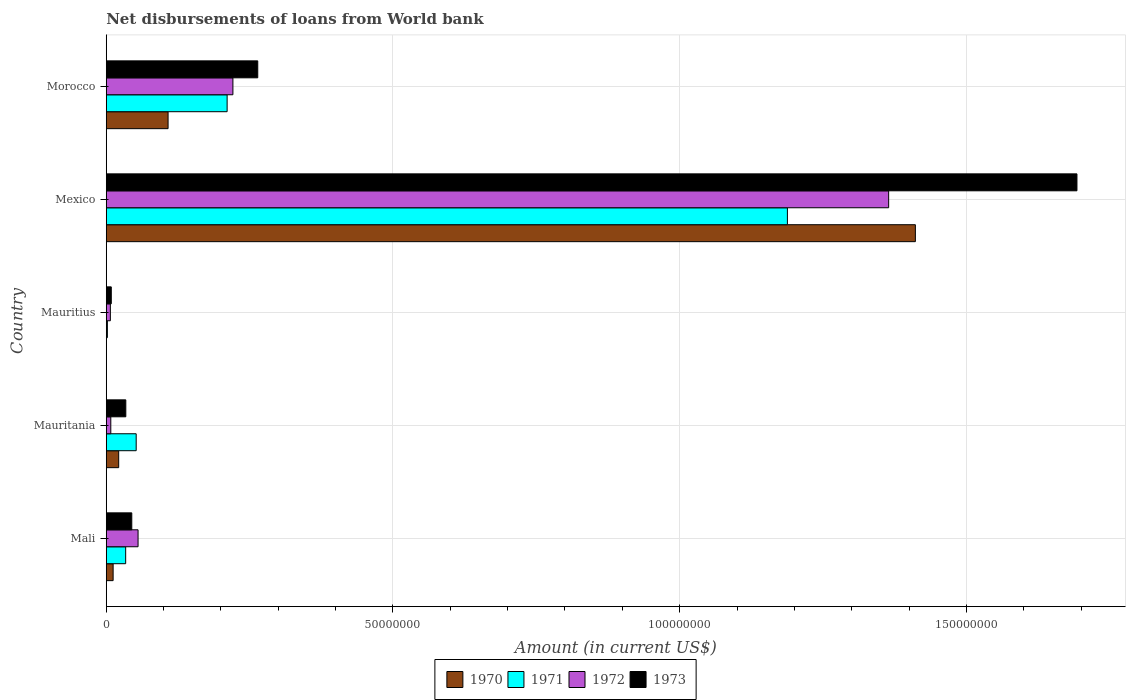How many groups of bars are there?
Make the answer very short. 5. Are the number of bars per tick equal to the number of legend labels?
Give a very brief answer. No. What is the label of the 3rd group of bars from the top?
Give a very brief answer. Mauritius. In how many cases, is the number of bars for a given country not equal to the number of legend labels?
Your answer should be compact. 1. What is the amount of loan disbursed from World Bank in 1972 in Mauritania?
Make the answer very short. 7.93e+05. Across all countries, what is the maximum amount of loan disbursed from World Bank in 1973?
Your response must be concise. 1.69e+08. Across all countries, what is the minimum amount of loan disbursed from World Bank in 1970?
Give a very brief answer. 0. What is the total amount of loan disbursed from World Bank in 1971 in the graph?
Ensure brevity in your answer.  1.49e+08. What is the difference between the amount of loan disbursed from World Bank in 1973 in Mali and that in Mauritius?
Provide a succinct answer. 3.57e+06. What is the difference between the amount of loan disbursed from World Bank in 1970 in Mauritius and the amount of loan disbursed from World Bank in 1972 in Mexico?
Ensure brevity in your answer.  -1.36e+08. What is the average amount of loan disbursed from World Bank in 1970 per country?
Your answer should be very brief. 3.11e+07. What is the difference between the amount of loan disbursed from World Bank in 1970 and amount of loan disbursed from World Bank in 1971 in Mauritania?
Offer a very short reply. -3.05e+06. What is the ratio of the amount of loan disbursed from World Bank in 1970 in Mauritania to that in Mexico?
Provide a short and direct response. 0.02. What is the difference between the highest and the second highest amount of loan disbursed from World Bank in 1973?
Give a very brief answer. 1.43e+08. What is the difference between the highest and the lowest amount of loan disbursed from World Bank in 1972?
Provide a short and direct response. 1.36e+08. Is the sum of the amount of loan disbursed from World Bank in 1972 in Mauritania and Mexico greater than the maximum amount of loan disbursed from World Bank in 1973 across all countries?
Keep it short and to the point. No. How many bars are there?
Provide a succinct answer. 19. What is the difference between two consecutive major ticks on the X-axis?
Give a very brief answer. 5.00e+07. Does the graph contain any zero values?
Give a very brief answer. Yes. Does the graph contain grids?
Ensure brevity in your answer.  Yes. What is the title of the graph?
Provide a succinct answer. Net disbursements of loans from World bank. Does "1988" appear as one of the legend labels in the graph?
Your answer should be compact. No. What is the label or title of the X-axis?
Your answer should be compact. Amount (in current US$). What is the label or title of the Y-axis?
Offer a terse response. Country. What is the Amount (in current US$) of 1970 in Mali?
Your answer should be very brief. 1.20e+06. What is the Amount (in current US$) in 1971 in Mali?
Provide a succinct answer. 3.39e+06. What is the Amount (in current US$) of 1972 in Mali?
Offer a very short reply. 5.55e+06. What is the Amount (in current US$) of 1973 in Mali?
Offer a very short reply. 4.45e+06. What is the Amount (in current US$) in 1970 in Mauritania?
Make the answer very short. 2.17e+06. What is the Amount (in current US$) of 1971 in Mauritania?
Give a very brief answer. 5.22e+06. What is the Amount (in current US$) of 1972 in Mauritania?
Keep it short and to the point. 7.93e+05. What is the Amount (in current US$) in 1973 in Mauritania?
Your response must be concise. 3.41e+06. What is the Amount (in current US$) in 1971 in Mauritius?
Make the answer very short. 1.99e+05. What is the Amount (in current US$) in 1972 in Mauritius?
Ensure brevity in your answer.  7.17e+05. What is the Amount (in current US$) in 1973 in Mauritius?
Keep it short and to the point. 8.79e+05. What is the Amount (in current US$) of 1970 in Mexico?
Offer a very short reply. 1.41e+08. What is the Amount (in current US$) in 1971 in Mexico?
Ensure brevity in your answer.  1.19e+08. What is the Amount (in current US$) in 1972 in Mexico?
Your answer should be very brief. 1.36e+08. What is the Amount (in current US$) in 1973 in Mexico?
Make the answer very short. 1.69e+08. What is the Amount (in current US$) in 1970 in Morocco?
Give a very brief answer. 1.08e+07. What is the Amount (in current US$) in 1971 in Morocco?
Your answer should be very brief. 2.11e+07. What is the Amount (in current US$) of 1972 in Morocco?
Your answer should be very brief. 2.21e+07. What is the Amount (in current US$) of 1973 in Morocco?
Ensure brevity in your answer.  2.64e+07. Across all countries, what is the maximum Amount (in current US$) of 1970?
Your response must be concise. 1.41e+08. Across all countries, what is the maximum Amount (in current US$) in 1971?
Your answer should be very brief. 1.19e+08. Across all countries, what is the maximum Amount (in current US$) of 1972?
Make the answer very short. 1.36e+08. Across all countries, what is the maximum Amount (in current US$) in 1973?
Provide a succinct answer. 1.69e+08. Across all countries, what is the minimum Amount (in current US$) of 1971?
Provide a short and direct response. 1.99e+05. Across all countries, what is the minimum Amount (in current US$) in 1972?
Make the answer very short. 7.17e+05. Across all countries, what is the minimum Amount (in current US$) of 1973?
Offer a very short reply. 8.79e+05. What is the total Amount (in current US$) of 1970 in the graph?
Your answer should be compact. 1.55e+08. What is the total Amount (in current US$) in 1971 in the graph?
Ensure brevity in your answer.  1.49e+08. What is the total Amount (in current US$) in 1972 in the graph?
Your answer should be very brief. 1.66e+08. What is the total Amount (in current US$) in 1973 in the graph?
Provide a short and direct response. 2.04e+08. What is the difference between the Amount (in current US$) of 1970 in Mali and that in Mauritania?
Ensure brevity in your answer.  -9.70e+05. What is the difference between the Amount (in current US$) in 1971 in Mali and that in Mauritania?
Give a very brief answer. -1.83e+06. What is the difference between the Amount (in current US$) in 1972 in Mali and that in Mauritania?
Provide a succinct answer. 4.76e+06. What is the difference between the Amount (in current US$) of 1973 in Mali and that in Mauritania?
Offer a terse response. 1.04e+06. What is the difference between the Amount (in current US$) in 1971 in Mali and that in Mauritius?
Provide a succinct answer. 3.19e+06. What is the difference between the Amount (in current US$) in 1972 in Mali and that in Mauritius?
Keep it short and to the point. 4.83e+06. What is the difference between the Amount (in current US$) in 1973 in Mali and that in Mauritius?
Give a very brief answer. 3.57e+06. What is the difference between the Amount (in current US$) of 1970 in Mali and that in Mexico?
Make the answer very short. -1.40e+08. What is the difference between the Amount (in current US$) in 1971 in Mali and that in Mexico?
Ensure brevity in your answer.  -1.15e+08. What is the difference between the Amount (in current US$) of 1972 in Mali and that in Mexico?
Your answer should be very brief. -1.31e+08. What is the difference between the Amount (in current US$) of 1973 in Mali and that in Mexico?
Provide a succinct answer. -1.65e+08. What is the difference between the Amount (in current US$) in 1970 in Mali and that in Morocco?
Your response must be concise. -9.58e+06. What is the difference between the Amount (in current US$) in 1971 in Mali and that in Morocco?
Your response must be concise. -1.77e+07. What is the difference between the Amount (in current US$) of 1972 in Mali and that in Morocco?
Make the answer very short. -1.65e+07. What is the difference between the Amount (in current US$) in 1973 in Mali and that in Morocco?
Offer a very short reply. -2.20e+07. What is the difference between the Amount (in current US$) in 1971 in Mauritania and that in Mauritius?
Ensure brevity in your answer.  5.02e+06. What is the difference between the Amount (in current US$) of 1972 in Mauritania and that in Mauritius?
Your answer should be very brief. 7.60e+04. What is the difference between the Amount (in current US$) of 1973 in Mauritania and that in Mauritius?
Give a very brief answer. 2.53e+06. What is the difference between the Amount (in current US$) of 1970 in Mauritania and that in Mexico?
Make the answer very short. -1.39e+08. What is the difference between the Amount (in current US$) of 1971 in Mauritania and that in Mexico?
Your response must be concise. -1.14e+08. What is the difference between the Amount (in current US$) in 1972 in Mauritania and that in Mexico?
Keep it short and to the point. -1.36e+08. What is the difference between the Amount (in current US$) of 1973 in Mauritania and that in Mexico?
Offer a very short reply. -1.66e+08. What is the difference between the Amount (in current US$) in 1970 in Mauritania and that in Morocco?
Provide a short and direct response. -8.61e+06. What is the difference between the Amount (in current US$) of 1971 in Mauritania and that in Morocco?
Your response must be concise. -1.59e+07. What is the difference between the Amount (in current US$) of 1972 in Mauritania and that in Morocco?
Provide a short and direct response. -2.13e+07. What is the difference between the Amount (in current US$) of 1973 in Mauritania and that in Morocco?
Keep it short and to the point. -2.30e+07. What is the difference between the Amount (in current US$) of 1971 in Mauritius and that in Mexico?
Provide a succinct answer. -1.19e+08. What is the difference between the Amount (in current US$) of 1972 in Mauritius and that in Mexico?
Ensure brevity in your answer.  -1.36e+08. What is the difference between the Amount (in current US$) of 1973 in Mauritius and that in Mexico?
Your response must be concise. -1.68e+08. What is the difference between the Amount (in current US$) in 1971 in Mauritius and that in Morocco?
Offer a terse response. -2.09e+07. What is the difference between the Amount (in current US$) in 1972 in Mauritius and that in Morocco?
Provide a succinct answer. -2.14e+07. What is the difference between the Amount (in current US$) of 1973 in Mauritius and that in Morocco?
Offer a very short reply. -2.55e+07. What is the difference between the Amount (in current US$) of 1970 in Mexico and that in Morocco?
Your answer should be compact. 1.30e+08. What is the difference between the Amount (in current US$) of 1971 in Mexico and that in Morocco?
Provide a short and direct response. 9.77e+07. What is the difference between the Amount (in current US$) in 1972 in Mexico and that in Morocco?
Provide a short and direct response. 1.14e+08. What is the difference between the Amount (in current US$) of 1973 in Mexico and that in Morocco?
Provide a short and direct response. 1.43e+08. What is the difference between the Amount (in current US$) in 1970 in Mali and the Amount (in current US$) in 1971 in Mauritania?
Offer a terse response. -4.02e+06. What is the difference between the Amount (in current US$) in 1970 in Mali and the Amount (in current US$) in 1972 in Mauritania?
Ensure brevity in your answer.  4.07e+05. What is the difference between the Amount (in current US$) of 1970 in Mali and the Amount (in current US$) of 1973 in Mauritania?
Give a very brief answer. -2.21e+06. What is the difference between the Amount (in current US$) in 1971 in Mali and the Amount (in current US$) in 1972 in Mauritania?
Ensure brevity in your answer.  2.60e+06. What is the difference between the Amount (in current US$) in 1971 in Mali and the Amount (in current US$) in 1973 in Mauritania?
Offer a terse response. -2.30e+04. What is the difference between the Amount (in current US$) of 1972 in Mali and the Amount (in current US$) of 1973 in Mauritania?
Ensure brevity in your answer.  2.14e+06. What is the difference between the Amount (in current US$) in 1970 in Mali and the Amount (in current US$) in 1971 in Mauritius?
Offer a very short reply. 1.00e+06. What is the difference between the Amount (in current US$) of 1970 in Mali and the Amount (in current US$) of 1972 in Mauritius?
Ensure brevity in your answer.  4.83e+05. What is the difference between the Amount (in current US$) of 1970 in Mali and the Amount (in current US$) of 1973 in Mauritius?
Your answer should be compact. 3.21e+05. What is the difference between the Amount (in current US$) of 1971 in Mali and the Amount (in current US$) of 1972 in Mauritius?
Make the answer very short. 2.67e+06. What is the difference between the Amount (in current US$) of 1971 in Mali and the Amount (in current US$) of 1973 in Mauritius?
Ensure brevity in your answer.  2.51e+06. What is the difference between the Amount (in current US$) in 1972 in Mali and the Amount (in current US$) in 1973 in Mauritius?
Your response must be concise. 4.67e+06. What is the difference between the Amount (in current US$) of 1970 in Mali and the Amount (in current US$) of 1971 in Mexico?
Provide a succinct answer. -1.18e+08. What is the difference between the Amount (in current US$) in 1970 in Mali and the Amount (in current US$) in 1972 in Mexico?
Provide a succinct answer. -1.35e+08. What is the difference between the Amount (in current US$) of 1970 in Mali and the Amount (in current US$) of 1973 in Mexico?
Your answer should be very brief. -1.68e+08. What is the difference between the Amount (in current US$) in 1971 in Mali and the Amount (in current US$) in 1972 in Mexico?
Ensure brevity in your answer.  -1.33e+08. What is the difference between the Amount (in current US$) in 1971 in Mali and the Amount (in current US$) in 1973 in Mexico?
Provide a succinct answer. -1.66e+08. What is the difference between the Amount (in current US$) of 1972 in Mali and the Amount (in current US$) of 1973 in Mexico?
Your answer should be compact. -1.64e+08. What is the difference between the Amount (in current US$) in 1970 in Mali and the Amount (in current US$) in 1971 in Morocco?
Your answer should be very brief. -1.99e+07. What is the difference between the Amount (in current US$) of 1970 in Mali and the Amount (in current US$) of 1972 in Morocco?
Make the answer very short. -2.09e+07. What is the difference between the Amount (in current US$) in 1970 in Mali and the Amount (in current US$) in 1973 in Morocco?
Give a very brief answer. -2.52e+07. What is the difference between the Amount (in current US$) of 1971 in Mali and the Amount (in current US$) of 1972 in Morocco?
Provide a short and direct response. -1.87e+07. What is the difference between the Amount (in current US$) in 1971 in Mali and the Amount (in current US$) in 1973 in Morocco?
Ensure brevity in your answer.  -2.30e+07. What is the difference between the Amount (in current US$) of 1972 in Mali and the Amount (in current US$) of 1973 in Morocco?
Ensure brevity in your answer.  -2.09e+07. What is the difference between the Amount (in current US$) in 1970 in Mauritania and the Amount (in current US$) in 1971 in Mauritius?
Give a very brief answer. 1.97e+06. What is the difference between the Amount (in current US$) of 1970 in Mauritania and the Amount (in current US$) of 1972 in Mauritius?
Give a very brief answer. 1.45e+06. What is the difference between the Amount (in current US$) in 1970 in Mauritania and the Amount (in current US$) in 1973 in Mauritius?
Provide a short and direct response. 1.29e+06. What is the difference between the Amount (in current US$) of 1971 in Mauritania and the Amount (in current US$) of 1972 in Mauritius?
Provide a succinct answer. 4.50e+06. What is the difference between the Amount (in current US$) in 1971 in Mauritania and the Amount (in current US$) in 1973 in Mauritius?
Keep it short and to the point. 4.34e+06. What is the difference between the Amount (in current US$) in 1972 in Mauritania and the Amount (in current US$) in 1973 in Mauritius?
Your answer should be very brief. -8.60e+04. What is the difference between the Amount (in current US$) of 1970 in Mauritania and the Amount (in current US$) of 1971 in Mexico?
Keep it short and to the point. -1.17e+08. What is the difference between the Amount (in current US$) in 1970 in Mauritania and the Amount (in current US$) in 1972 in Mexico?
Provide a succinct answer. -1.34e+08. What is the difference between the Amount (in current US$) in 1970 in Mauritania and the Amount (in current US$) in 1973 in Mexico?
Make the answer very short. -1.67e+08. What is the difference between the Amount (in current US$) of 1971 in Mauritania and the Amount (in current US$) of 1972 in Mexico?
Keep it short and to the point. -1.31e+08. What is the difference between the Amount (in current US$) of 1971 in Mauritania and the Amount (in current US$) of 1973 in Mexico?
Your response must be concise. -1.64e+08. What is the difference between the Amount (in current US$) in 1972 in Mauritania and the Amount (in current US$) in 1973 in Mexico?
Your answer should be very brief. -1.68e+08. What is the difference between the Amount (in current US$) in 1970 in Mauritania and the Amount (in current US$) in 1971 in Morocco?
Your answer should be very brief. -1.89e+07. What is the difference between the Amount (in current US$) of 1970 in Mauritania and the Amount (in current US$) of 1972 in Morocco?
Give a very brief answer. -1.99e+07. What is the difference between the Amount (in current US$) in 1970 in Mauritania and the Amount (in current US$) in 1973 in Morocco?
Your answer should be very brief. -2.43e+07. What is the difference between the Amount (in current US$) of 1971 in Mauritania and the Amount (in current US$) of 1972 in Morocco?
Offer a very short reply. -1.69e+07. What is the difference between the Amount (in current US$) of 1971 in Mauritania and the Amount (in current US$) of 1973 in Morocco?
Your response must be concise. -2.12e+07. What is the difference between the Amount (in current US$) of 1972 in Mauritania and the Amount (in current US$) of 1973 in Morocco?
Offer a terse response. -2.56e+07. What is the difference between the Amount (in current US$) in 1971 in Mauritius and the Amount (in current US$) in 1972 in Mexico?
Your response must be concise. -1.36e+08. What is the difference between the Amount (in current US$) in 1971 in Mauritius and the Amount (in current US$) in 1973 in Mexico?
Provide a short and direct response. -1.69e+08. What is the difference between the Amount (in current US$) of 1972 in Mauritius and the Amount (in current US$) of 1973 in Mexico?
Offer a very short reply. -1.69e+08. What is the difference between the Amount (in current US$) in 1971 in Mauritius and the Amount (in current US$) in 1972 in Morocco?
Offer a very short reply. -2.19e+07. What is the difference between the Amount (in current US$) of 1971 in Mauritius and the Amount (in current US$) of 1973 in Morocco?
Your answer should be very brief. -2.62e+07. What is the difference between the Amount (in current US$) in 1972 in Mauritius and the Amount (in current US$) in 1973 in Morocco?
Your response must be concise. -2.57e+07. What is the difference between the Amount (in current US$) of 1970 in Mexico and the Amount (in current US$) of 1971 in Morocco?
Give a very brief answer. 1.20e+08. What is the difference between the Amount (in current US$) in 1970 in Mexico and the Amount (in current US$) in 1972 in Morocco?
Give a very brief answer. 1.19e+08. What is the difference between the Amount (in current US$) in 1970 in Mexico and the Amount (in current US$) in 1973 in Morocco?
Offer a terse response. 1.15e+08. What is the difference between the Amount (in current US$) of 1971 in Mexico and the Amount (in current US$) of 1972 in Morocco?
Provide a succinct answer. 9.67e+07. What is the difference between the Amount (in current US$) in 1971 in Mexico and the Amount (in current US$) in 1973 in Morocco?
Ensure brevity in your answer.  9.24e+07. What is the difference between the Amount (in current US$) in 1972 in Mexico and the Amount (in current US$) in 1973 in Morocco?
Your answer should be very brief. 1.10e+08. What is the average Amount (in current US$) in 1970 per country?
Your answer should be compact. 3.11e+07. What is the average Amount (in current US$) in 1971 per country?
Your answer should be very brief. 2.97e+07. What is the average Amount (in current US$) in 1972 per country?
Your answer should be compact. 3.31e+07. What is the average Amount (in current US$) of 1973 per country?
Offer a terse response. 4.09e+07. What is the difference between the Amount (in current US$) in 1970 and Amount (in current US$) in 1971 in Mali?
Your answer should be compact. -2.19e+06. What is the difference between the Amount (in current US$) in 1970 and Amount (in current US$) in 1972 in Mali?
Offer a very short reply. -4.35e+06. What is the difference between the Amount (in current US$) of 1970 and Amount (in current US$) of 1973 in Mali?
Provide a succinct answer. -3.25e+06. What is the difference between the Amount (in current US$) in 1971 and Amount (in current US$) in 1972 in Mali?
Your answer should be compact. -2.16e+06. What is the difference between the Amount (in current US$) of 1971 and Amount (in current US$) of 1973 in Mali?
Your answer should be compact. -1.06e+06. What is the difference between the Amount (in current US$) of 1972 and Amount (in current US$) of 1973 in Mali?
Your response must be concise. 1.10e+06. What is the difference between the Amount (in current US$) in 1970 and Amount (in current US$) in 1971 in Mauritania?
Offer a very short reply. -3.05e+06. What is the difference between the Amount (in current US$) of 1970 and Amount (in current US$) of 1972 in Mauritania?
Ensure brevity in your answer.  1.38e+06. What is the difference between the Amount (in current US$) of 1970 and Amount (in current US$) of 1973 in Mauritania?
Offer a very short reply. -1.24e+06. What is the difference between the Amount (in current US$) of 1971 and Amount (in current US$) of 1972 in Mauritania?
Your answer should be very brief. 4.43e+06. What is the difference between the Amount (in current US$) of 1971 and Amount (in current US$) of 1973 in Mauritania?
Your answer should be very brief. 1.81e+06. What is the difference between the Amount (in current US$) of 1972 and Amount (in current US$) of 1973 in Mauritania?
Provide a short and direct response. -2.62e+06. What is the difference between the Amount (in current US$) of 1971 and Amount (in current US$) of 1972 in Mauritius?
Your answer should be very brief. -5.18e+05. What is the difference between the Amount (in current US$) in 1971 and Amount (in current US$) in 1973 in Mauritius?
Give a very brief answer. -6.80e+05. What is the difference between the Amount (in current US$) of 1972 and Amount (in current US$) of 1973 in Mauritius?
Offer a terse response. -1.62e+05. What is the difference between the Amount (in current US$) in 1970 and Amount (in current US$) in 1971 in Mexico?
Provide a succinct answer. 2.23e+07. What is the difference between the Amount (in current US$) of 1970 and Amount (in current US$) of 1972 in Mexico?
Your answer should be compact. 4.66e+06. What is the difference between the Amount (in current US$) in 1970 and Amount (in current US$) in 1973 in Mexico?
Offer a very short reply. -2.82e+07. What is the difference between the Amount (in current US$) in 1971 and Amount (in current US$) in 1972 in Mexico?
Your answer should be very brief. -1.77e+07. What is the difference between the Amount (in current US$) in 1971 and Amount (in current US$) in 1973 in Mexico?
Your answer should be very brief. -5.05e+07. What is the difference between the Amount (in current US$) in 1972 and Amount (in current US$) in 1973 in Mexico?
Offer a terse response. -3.28e+07. What is the difference between the Amount (in current US$) in 1970 and Amount (in current US$) in 1971 in Morocco?
Your answer should be very brief. -1.03e+07. What is the difference between the Amount (in current US$) in 1970 and Amount (in current US$) in 1972 in Morocco?
Provide a succinct answer. -1.13e+07. What is the difference between the Amount (in current US$) in 1970 and Amount (in current US$) in 1973 in Morocco?
Make the answer very short. -1.56e+07. What is the difference between the Amount (in current US$) in 1971 and Amount (in current US$) in 1972 in Morocco?
Provide a short and direct response. -1.01e+06. What is the difference between the Amount (in current US$) in 1971 and Amount (in current US$) in 1973 in Morocco?
Your response must be concise. -5.34e+06. What is the difference between the Amount (in current US$) in 1972 and Amount (in current US$) in 1973 in Morocco?
Give a very brief answer. -4.33e+06. What is the ratio of the Amount (in current US$) of 1970 in Mali to that in Mauritania?
Your answer should be compact. 0.55. What is the ratio of the Amount (in current US$) in 1971 in Mali to that in Mauritania?
Give a very brief answer. 0.65. What is the ratio of the Amount (in current US$) in 1972 in Mali to that in Mauritania?
Provide a short and direct response. 7. What is the ratio of the Amount (in current US$) of 1973 in Mali to that in Mauritania?
Offer a terse response. 1.31. What is the ratio of the Amount (in current US$) of 1971 in Mali to that in Mauritius?
Your response must be concise. 17.03. What is the ratio of the Amount (in current US$) of 1972 in Mali to that in Mauritius?
Your response must be concise. 7.74. What is the ratio of the Amount (in current US$) of 1973 in Mali to that in Mauritius?
Offer a very short reply. 5.06. What is the ratio of the Amount (in current US$) of 1970 in Mali to that in Mexico?
Keep it short and to the point. 0.01. What is the ratio of the Amount (in current US$) in 1971 in Mali to that in Mexico?
Your response must be concise. 0.03. What is the ratio of the Amount (in current US$) of 1972 in Mali to that in Mexico?
Provide a short and direct response. 0.04. What is the ratio of the Amount (in current US$) in 1973 in Mali to that in Mexico?
Keep it short and to the point. 0.03. What is the ratio of the Amount (in current US$) in 1970 in Mali to that in Morocco?
Keep it short and to the point. 0.11. What is the ratio of the Amount (in current US$) of 1971 in Mali to that in Morocco?
Your answer should be very brief. 0.16. What is the ratio of the Amount (in current US$) of 1972 in Mali to that in Morocco?
Your answer should be compact. 0.25. What is the ratio of the Amount (in current US$) in 1973 in Mali to that in Morocco?
Your answer should be very brief. 0.17. What is the ratio of the Amount (in current US$) of 1971 in Mauritania to that in Mauritius?
Your response must be concise. 26.24. What is the ratio of the Amount (in current US$) of 1972 in Mauritania to that in Mauritius?
Keep it short and to the point. 1.11. What is the ratio of the Amount (in current US$) in 1973 in Mauritania to that in Mauritius?
Your answer should be compact. 3.88. What is the ratio of the Amount (in current US$) of 1970 in Mauritania to that in Mexico?
Your answer should be very brief. 0.02. What is the ratio of the Amount (in current US$) of 1971 in Mauritania to that in Mexico?
Make the answer very short. 0.04. What is the ratio of the Amount (in current US$) in 1972 in Mauritania to that in Mexico?
Provide a succinct answer. 0.01. What is the ratio of the Amount (in current US$) of 1973 in Mauritania to that in Mexico?
Offer a very short reply. 0.02. What is the ratio of the Amount (in current US$) of 1970 in Mauritania to that in Morocco?
Provide a succinct answer. 0.2. What is the ratio of the Amount (in current US$) in 1971 in Mauritania to that in Morocco?
Ensure brevity in your answer.  0.25. What is the ratio of the Amount (in current US$) of 1972 in Mauritania to that in Morocco?
Your response must be concise. 0.04. What is the ratio of the Amount (in current US$) of 1973 in Mauritania to that in Morocco?
Ensure brevity in your answer.  0.13. What is the ratio of the Amount (in current US$) of 1971 in Mauritius to that in Mexico?
Provide a short and direct response. 0. What is the ratio of the Amount (in current US$) in 1972 in Mauritius to that in Mexico?
Provide a succinct answer. 0.01. What is the ratio of the Amount (in current US$) of 1973 in Mauritius to that in Mexico?
Give a very brief answer. 0.01. What is the ratio of the Amount (in current US$) in 1971 in Mauritius to that in Morocco?
Keep it short and to the point. 0.01. What is the ratio of the Amount (in current US$) of 1972 in Mauritius to that in Morocco?
Keep it short and to the point. 0.03. What is the ratio of the Amount (in current US$) in 1970 in Mexico to that in Morocco?
Offer a terse response. 13.09. What is the ratio of the Amount (in current US$) of 1971 in Mexico to that in Morocco?
Ensure brevity in your answer.  5.63. What is the ratio of the Amount (in current US$) in 1972 in Mexico to that in Morocco?
Your response must be concise. 6.18. What is the ratio of the Amount (in current US$) of 1973 in Mexico to that in Morocco?
Your answer should be compact. 6.41. What is the difference between the highest and the second highest Amount (in current US$) in 1970?
Ensure brevity in your answer.  1.30e+08. What is the difference between the highest and the second highest Amount (in current US$) of 1971?
Your answer should be very brief. 9.77e+07. What is the difference between the highest and the second highest Amount (in current US$) in 1972?
Provide a short and direct response. 1.14e+08. What is the difference between the highest and the second highest Amount (in current US$) of 1973?
Offer a terse response. 1.43e+08. What is the difference between the highest and the lowest Amount (in current US$) of 1970?
Make the answer very short. 1.41e+08. What is the difference between the highest and the lowest Amount (in current US$) of 1971?
Provide a succinct answer. 1.19e+08. What is the difference between the highest and the lowest Amount (in current US$) of 1972?
Your answer should be compact. 1.36e+08. What is the difference between the highest and the lowest Amount (in current US$) of 1973?
Keep it short and to the point. 1.68e+08. 